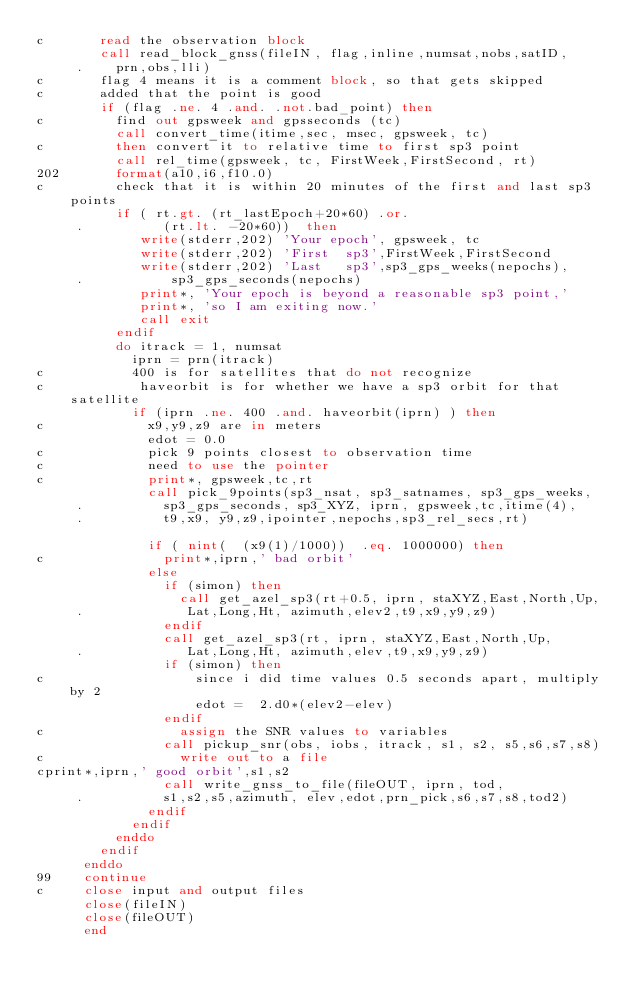<code> <loc_0><loc_0><loc_500><loc_500><_FORTRAN_>c       read the observation block
        call read_block_gnss(fileIN, flag,inline,numsat,nobs,satID,
     .    prn,obs,lli)
c       flag 4 means it is a comment block, so that gets skipped
c       added that the point is good
        if (flag .ne. 4 .and. .not.bad_point) then
c         find out gpsweek and gpsseconds (tc)
          call convert_time(itime,sec, msec, gpsweek, tc)
c         then convert it to relative time to first sp3 point 
          call rel_time(gpsweek, tc, FirstWeek,FirstSecond, rt)
202       format(a10,i6,f10.0)
c         check that it is within 20 minutes of the first and last sp3 points
          if ( rt.gt. (rt_lastEpoch+20*60) .or. 
     .          (rt.lt. -20*60))  then
             write(stderr,202) 'Your epoch', gpsweek, tc
             write(stderr,202) 'First  sp3',FirstWeek,FirstSecond
             write(stderr,202) 'Last   sp3',sp3_gps_weeks(nepochs), 
     .           sp3_gps_seconds(nepochs)
             print*, 'Your epoch is beyond a reasonable sp3 point,'
             print*, 'so I am exiting now.'
             call exit
          endif
          do itrack = 1, numsat
            iprn = prn(itrack)
c           400 is for satellites that do not recognize
c            haveorbit is for whether we have a sp3 orbit for that satellite
            if (iprn .ne. 400 .and. haveorbit(iprn) ) then
c             x9,y9,z9 are in meters
              edot = 0.0
c             pick 9 points closest to observation time
c             need to use the pointer
c             print*, gpsweek,tc,rt
              call pick_9points(sp3_nsat, sp3_satnames, sp3_gps_weeks,
     .          sp3_gps_seconds, sp3_XYZ, iprn, gpsweek,tc,itime(4),
     .          t9,x9, y9,z9,ipointer,nepochs,sp3_rel_secs,rt)
               
              if ( nint(  (x9(1)/1000))  .eq. 1000000) then
c               print*,iprn,' bad orbit'
              else
                if (simon) then
                  call get_azel_sp3(rt+0.5, iprn, staXYZ,East,North,Up,
     .             Lat,Long,Ht, azimuth,elev2,t9,x9,y9,z9)
                endif
                call get_azel_sp3(rt, iprn, staXYZ,East,North,Up,
     .             Lat,Long,Ht, azimuth,elev,t9,x9,y9,z9)
                if (simon) then
c                   since i did time values 0.5 seconds apart, multiply by 2
                    edot =  2.d0*(elev2-elev)
                endif
c                 assign the SNR values to variables
                call pickup_snr(obs, iobs, itrack, s1, s2, s5,s6,s7,s8)
c                 write out to a file
cprint*,iprn,' good orbit',s1,s2  
                call write_gnss_to_file(fileOUT, iprn, tod,
     .          s1,s2,s5,azimuth, elev,edot,prn_pick,s6,s7,s8,tod2)
              endif
            endif
          enddo
        endif
      enddo
99    continue
c     close input and output files
      close(fileIN)
      close(fileOUT)
      end
</code> 